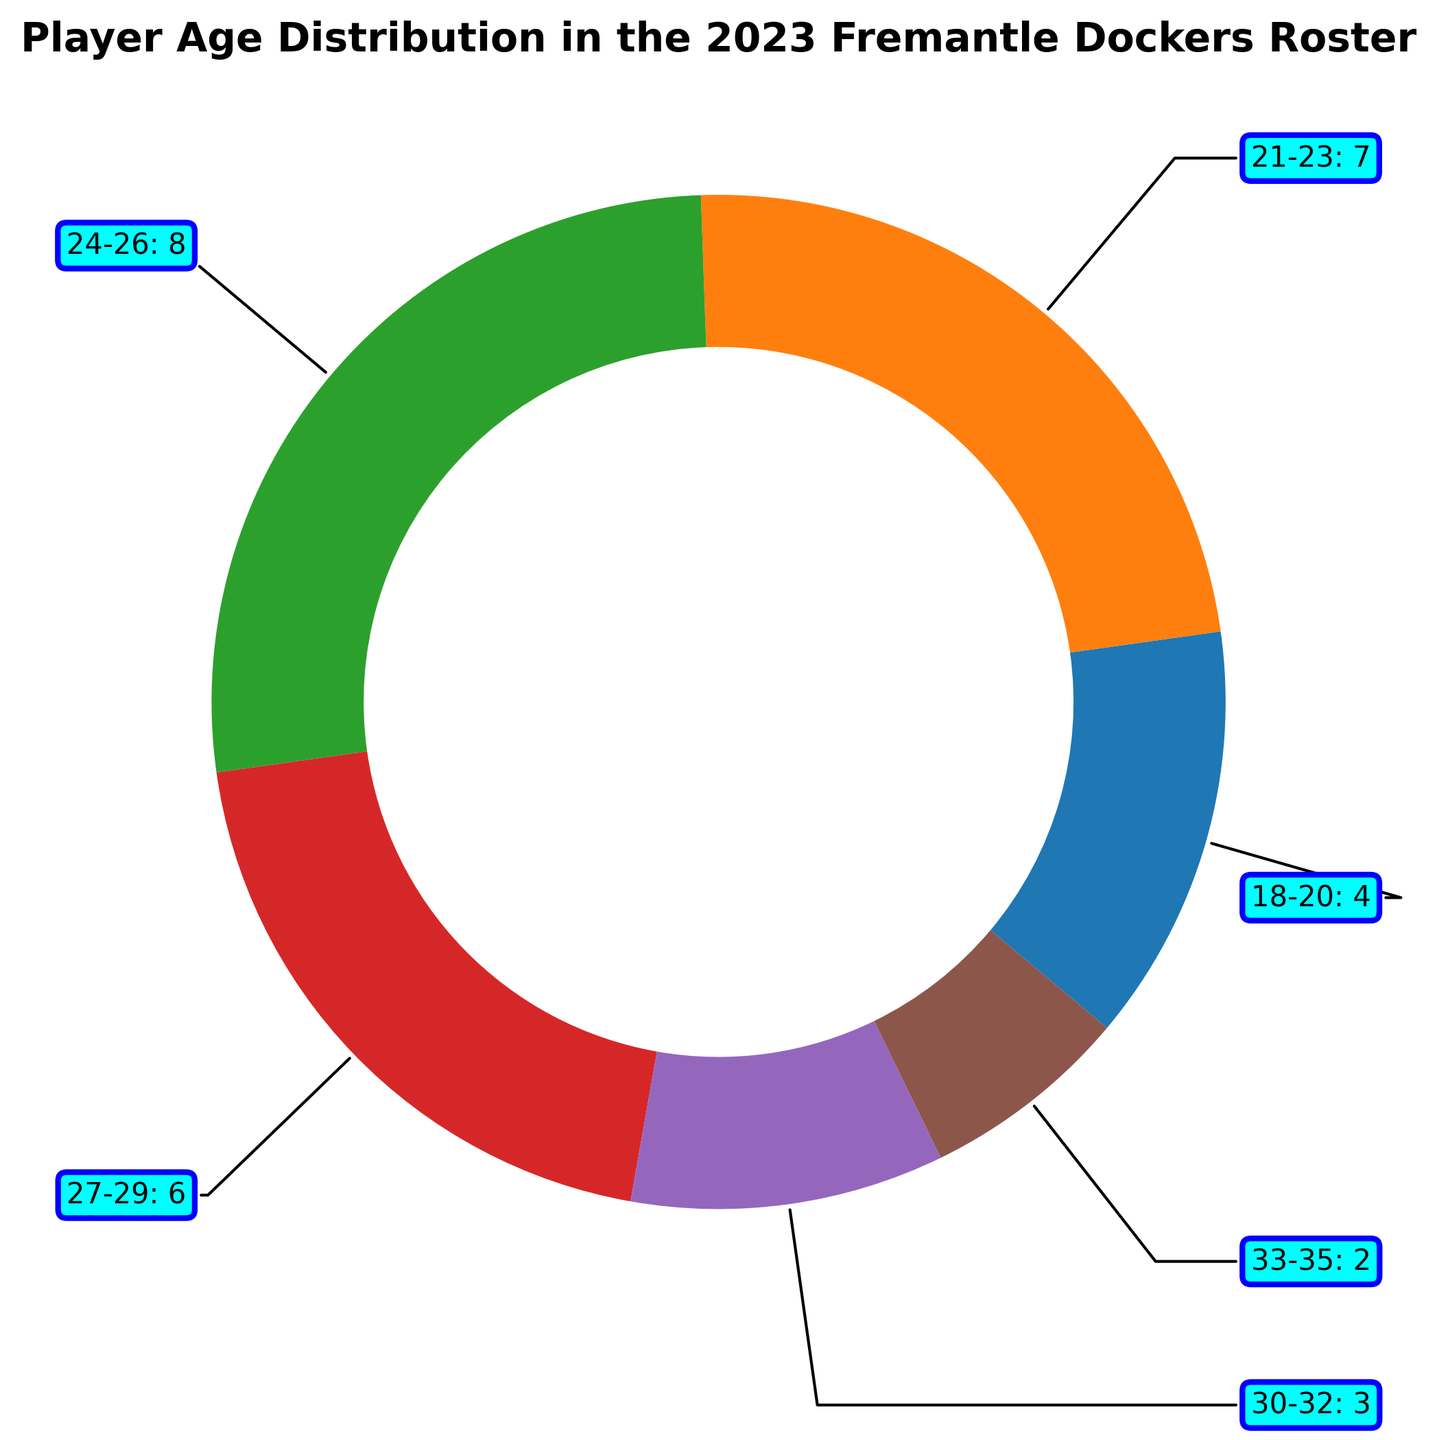what is the total number of players in the roster? Sum all the counts from each age range: (4 + 7 + 8 + 6 + 3 + 2) = 30
Answer: 30 which age range has the largest number of players? Look for the age range with the highest count. The age range 24-26 has the highest count of 8.
Answer: 24-26 how many more players are there in the 21-23 age range compared to the 30-32 age range? Subtract the count of the 30-32 age range from the count of the 21-23 age range: 7 - 3 = 4
Answer: 4 what percentage of the roster is in the 27-29 age range? Divide the count of the 27-29 age range by the total number of players and multiply by 100: (6 / 30) * 100 = 20%
Answer: 20% are there more players aged 18-20 than those aged 33-35? Compare the counts of players aged 18-20 (4) and the counts of players aged 33-35 (2). Since 4 is greater than 2, the answer is yes.
Answer: yes what is the proportion of players aged 24-26 to players aged 18-20? Divide the count of the 24-26 age range by the count of the 18-20 age range: 8 / 4 = 2
Answer: 2 is the number of players aged 24-26 greater than the combined number of players aged 18-20 and 33-35? Add the counts of the 18-20 age range and the 33-35 age range: 4 + 2 = 6. Compare this sum to the count of the 24-26 age range (8). Since 8 is greater than 6, the answer is yes.
Answer: yes what is the age range with the smallest number of players? Look for the age range with the lowest count. The age range 33-35 has the lowest count of 2.
Answer: 33-35 